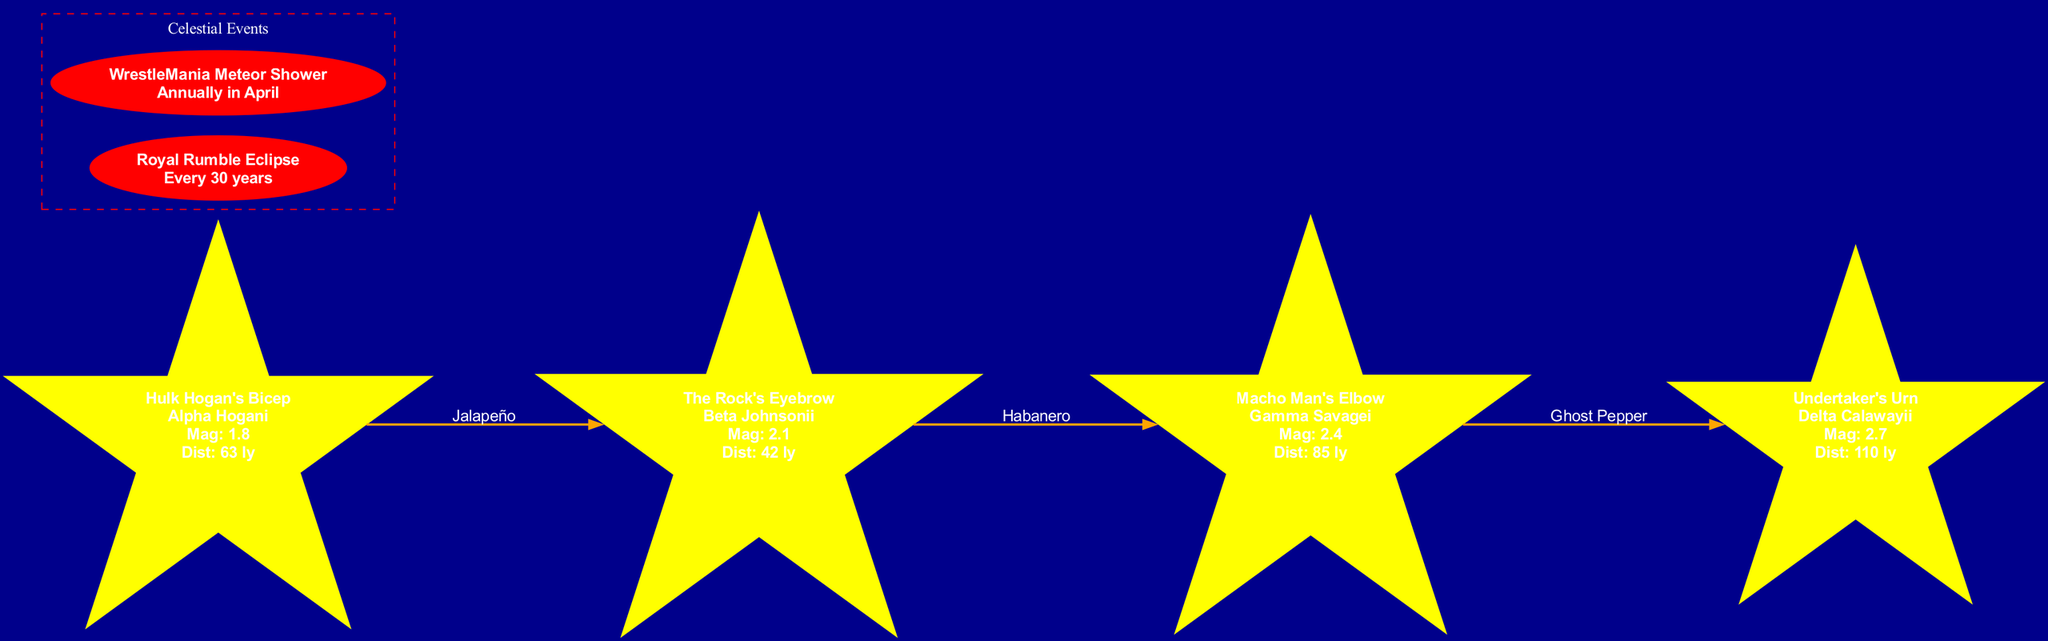What is the brightest star in "Hulk Hogan's Bicep"? According to the diagram, the brightest star in "Hulk Hogan's Bicep" is listed as "Alpha Hogani".
Answer: Alpha Hogani What is the magnitude of "Undertaker's Urn"? The magnitude for "Undertaker's Urn" is provided in the diagram as 2.7.
Answer: 2.7 How many celestial events are shown in the diagram? The diagram displays a total of two celestial events, namely the "Royal Rumble Eclipse" and the "WrestleMania Meteor Shower".
Answer: 2 What is the spice level between "The Rock's Eyebrow" and "Macho Man's Elbow"? The diagram indicates that the spice level connecting "The Rock's Eyebrow" to "Macho Man's Elbow" is "Habanero".
Answer: Habanero Which constellation is the furthest from Earth? By analyzing the distances, "Undertaker's Urn" has the greatest distance of 110 light-years, making it the furthest from Earth.
Answer: Undertaker's Urn Which star has a magnitude lower than 2.0? The only star listed with a magnitude below 2.0 is "Alpha Hogani" from the constellation "Hulk Hogan's Bicep", which has a magnitude of 1.8.
Answer: Alpha Hogani What event occurs annually in April? The diagram states that the "WrestleMania Meteor Shower" occurs annually in April.
Answer: WrestleMania Meteor Shower How many connections are made from "Macho Man's Elbow"? The diagram shows one outgoing connection from "Macho Man's Elbow" to "Undertaker's Urn."
Answer: 1 What is the spice level between "Hulk Hogan's Bicep" and "The Rock's Eyebrow"? The spice level connecting "Hulk Hogan's Bicep" to "The Rock's Eyebrow" is identified as "Jalapeño".
Answer: Jalapeño 